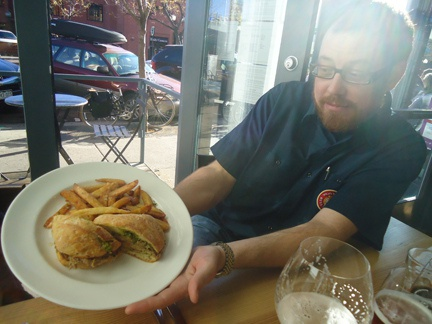Describe the objects in this image and their specific colors. I can see people in black, gray, purple, and lightgray tones, wine glass in black, olive, gray, and darkgray tones, dining table in black, olive, and maroon tones, car in black, gray, lavender, and navy tones, and sandwich in black, olive, tan, and maroon tones in this image. 